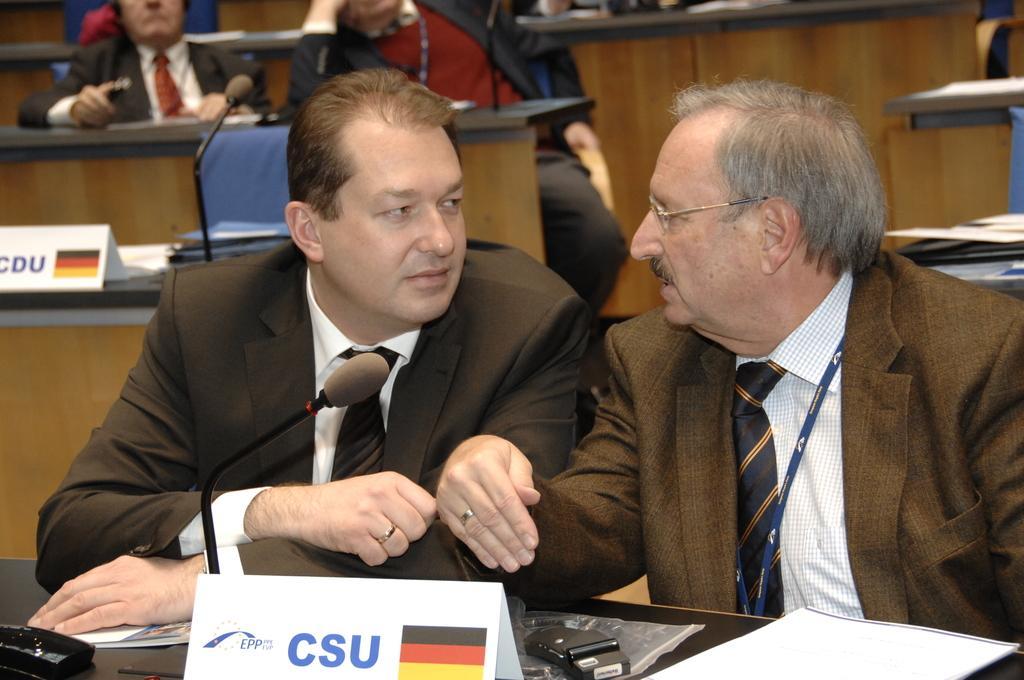In one or two sentences, can you explain what this image depicts? There are two persons wearing suits and sitting and there is a table in front of them, Which has mic and some other objects on it and there are few other people sitting behind them. 